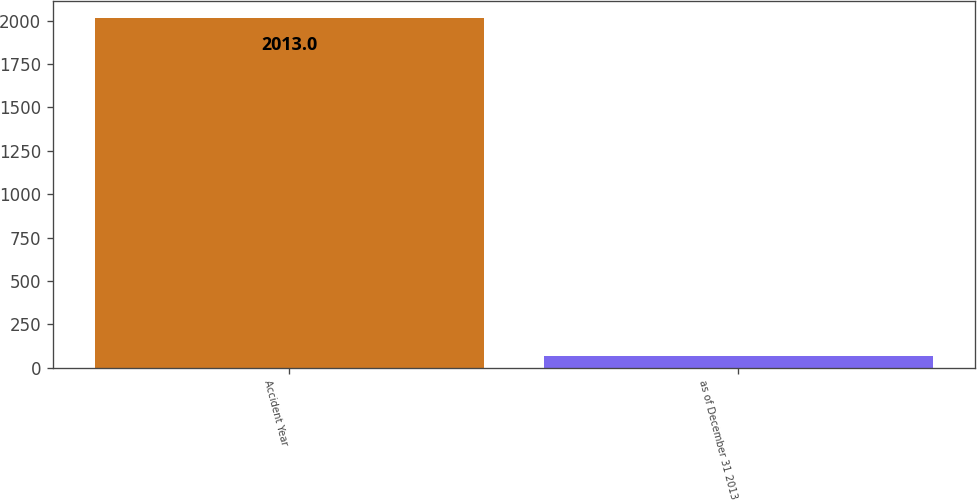<chart> <loc_0><loc_0><loc_500><loc_500><bar_chart><fcel>Accident Year<fcel>as of December 31 2013<nl><fcel>2013<fcel>66<nl></chart> 